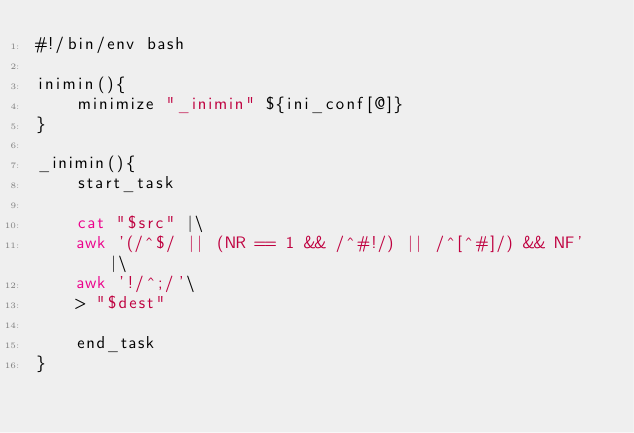<code> <loc_0><loc_0><loc_500><loc_500><_Bash_>#!/bin/env bash

inimin(){
    minimize "_inimin" ${ini_conf[@]}
}

_inimin(){
    start_task
    
    cat "$src" |\
    awk '(/^$/ || (NR == 1 && /^#!/) || /^[^#]/) && NF' |\
    awk '!/^;/'\
    > "$dest"
    
    end_task
}
</code> 